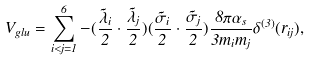Convert formula to latex. <formula><loc_0><loc_0><loc_500><loc_500>V _ { g l u } = \sum _ { i < j = 1 } ^ { 6 } - ( \frac { \vec { \lambda } _ { i } } { 2 } \cdot \frac { \vec { \lambda } _ { j } } { 2 } ) ( \frac { \vec { \sigma } _ { i } } { 2 } \cdot \frac { \vec { \sigma } _ { j } } { 2 } ) \frac { 8 \pi \alpha _ { s } } { 3 m _ { i } m _ { j } } \delta ^ { ( 3 ) } ( r _ { i j } ) ,</formula> 